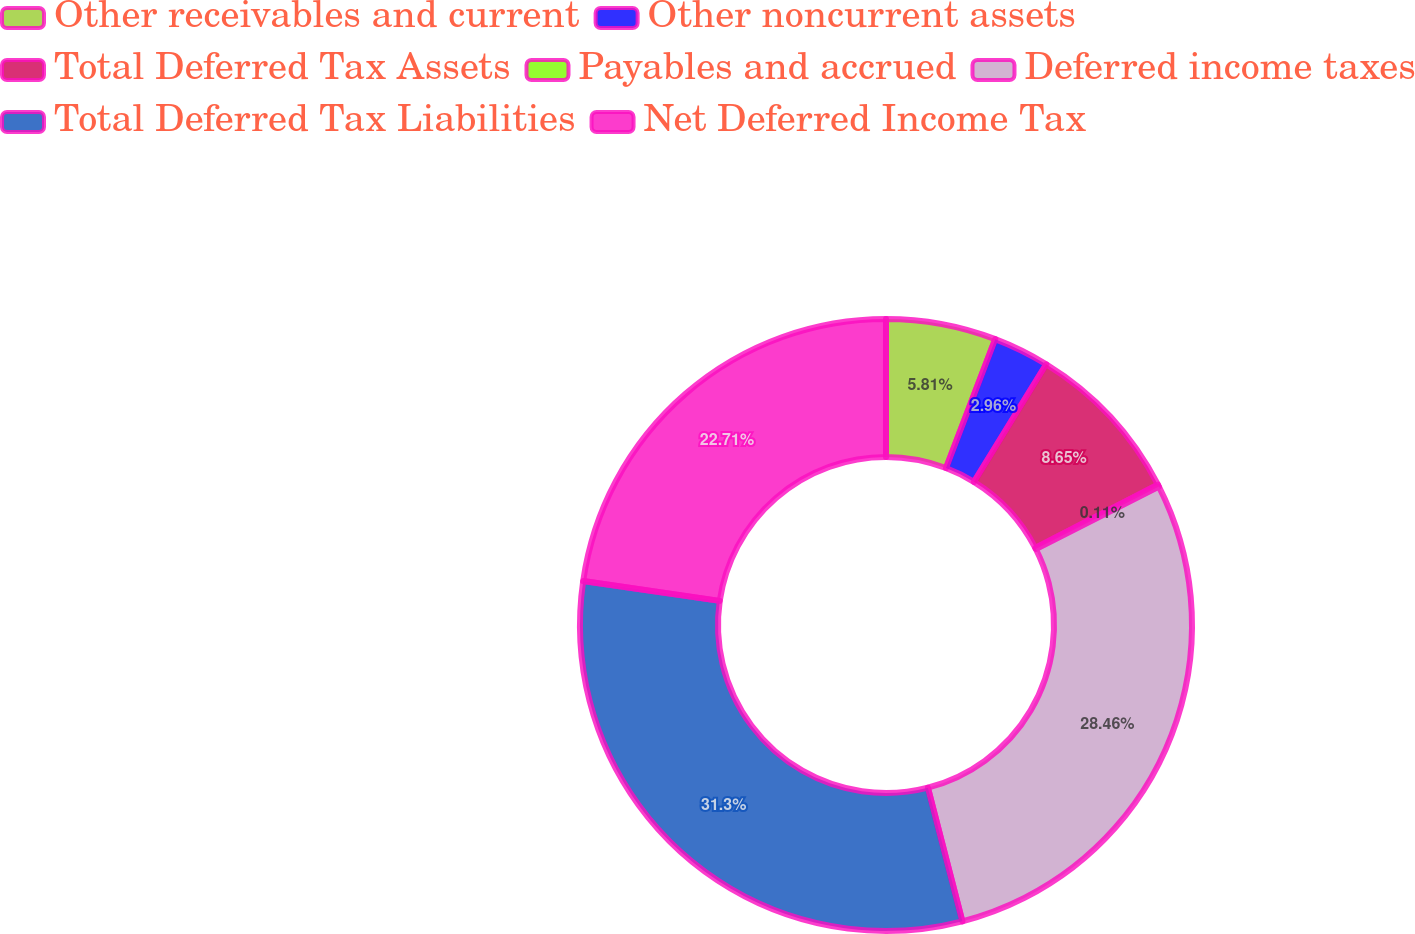<chart> <loc_0><loc_0><loc_500><loc_500><pie_chart><fcel>Other receivables and current<fcel>Other noncurrent assets<fcel>Total Deferred Tax Assets<fcel>Payables and accrued<fcel>Deferred income taxes<fcel>Total Deferred Tax Liabilities<fcel>Net Deferred Income Tax<nl><fcel>5.81%<fcel>2.96%<fcel>8.65%<fcel>0.11%<fcel>28.46%<fcel>31.31%<fcel>22.71%<nl></chart> 